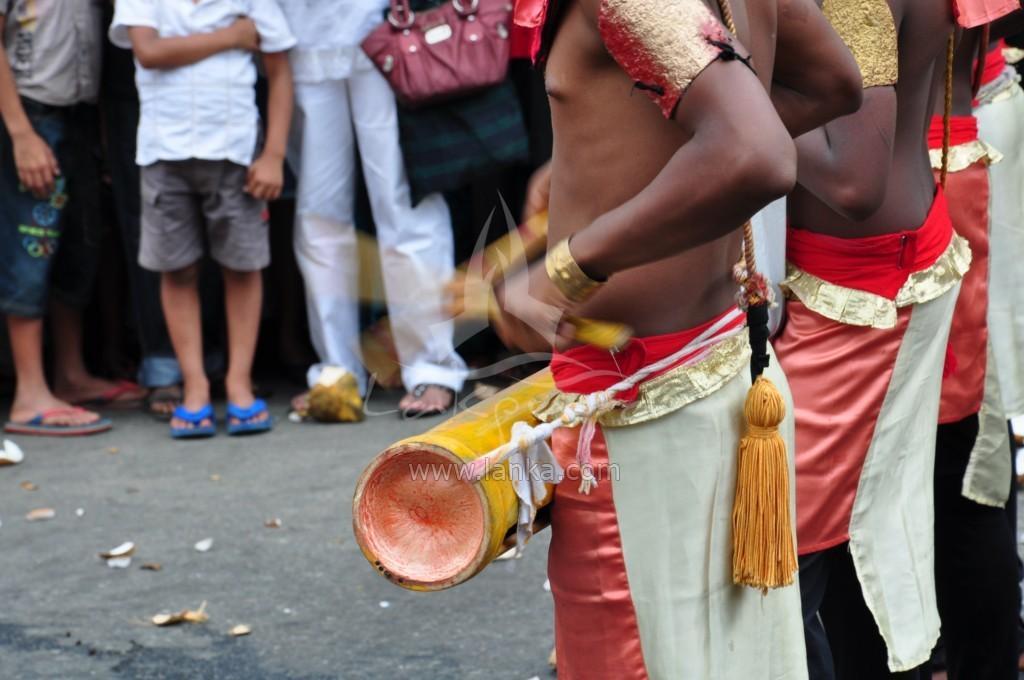How would you summarize this image in a sentence or two? In this image i can see a group of people are standing on the road. 